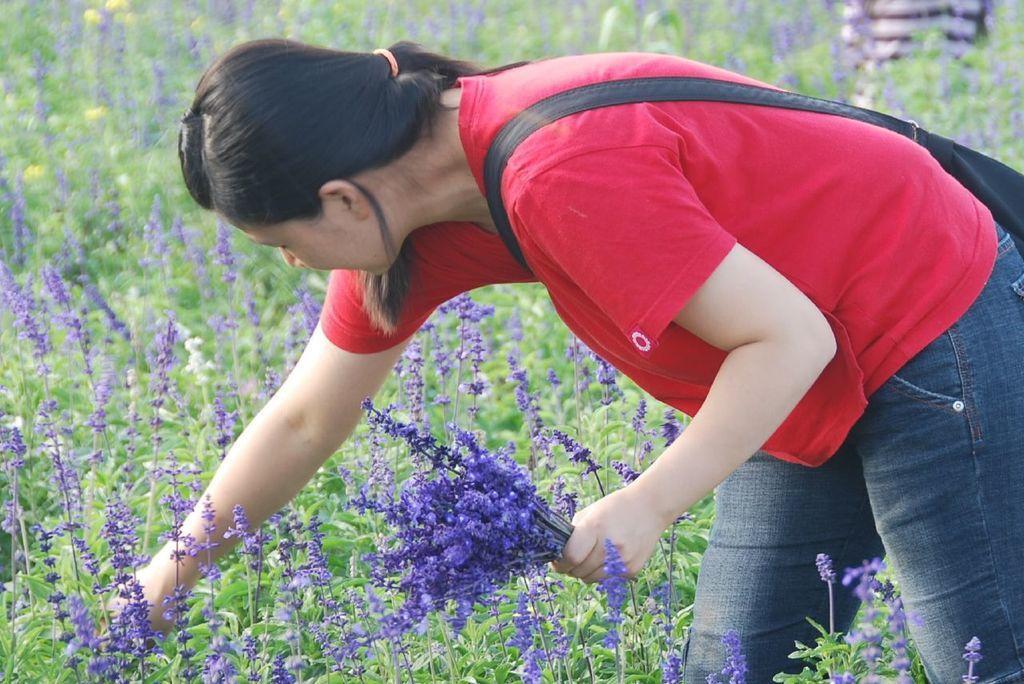Could you give a brief overview of what you see in this image? In this image there is a person plucking the flowers and we can see plants with flowers. 